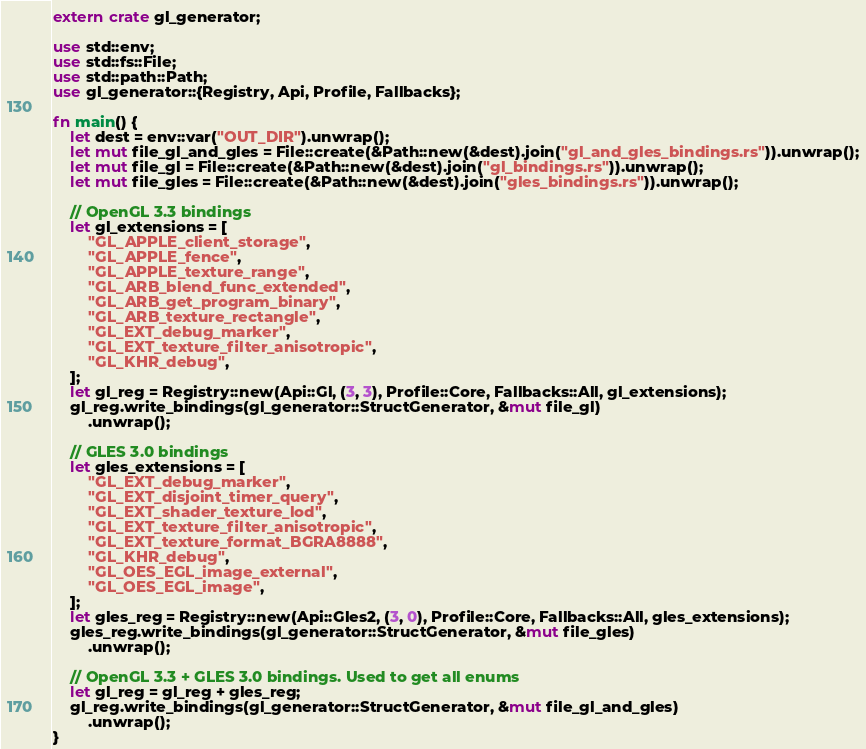<code> <loc_0><loc_0><loc_500><loc_500><_Rust_>extern crate gl_generator;

use std::env;
use std::fs::File;
use std::path::Path;
use gl_generator::{Registry, Api, Profile, Fallbacks};

fn main() {
    let dest = env::var("OUT_DIR").unwrap();
    let mut file_gl_and_gles = File::create(&Path::new(&dest).join("gl_and_gles_bindings.rs")).unwrap();
    let mut file_gl = File::create(&Path::new(&dest).join("gl_bindings.rs")).unwrap();
    let mut file_gles = File::create(&Path::new(&dest).join("gles_bindings.rs")).unwrap();

    // OpenGL 3.3 bindings
    let gl_extensions = [
        "GL_APPLE_client_storage",
        "GL_APPLE_fence",
        "GL_APPLE_texture_range",
        "GL_ARB_blend_func_extended",
        "GL_ARB_get_program_binary",
        "GL_ARB_texture_rectangle",
        "GL_EXT_debug_marker",
        "GL_EXT_texture_filter_anisotropic",
        "GL_KHR_debug",
    ];
    let gl_reg = Registry::new(Api::Gl, (3, 3), Profile::Core, Fallbacks::All, gl_extensions);
    gl_reg.write_bindings(gl_generator::StructGenerator, &mut file_gl)
        .unwrap();

    // GLES 3.0 bindings
    let gles_extensions = [
        "GL_EXT_debug_marker",
        "GL_EXT_disjoint_timer_query",
        "GL_EXT_shader_texture_lod",
        "GL_EXT_texture_filter_anisotropic",
        "GL_EXT_texture_format_BGRA8888",
        "GL_KHR_debug",
        "GL_OES_EGL_image_external",
        "GL_OES_EGL_image",
    ];
    let gles_reg = Registry::new(Api::Gles2, (3, 0), Profile::Core, Fallbacks::All, gles_extensions);
    gles_reg.write_bindings(gl_generator::StructGenerator, &mut file_gles)
        .unwrap();

    // OpenGL 3.3 + GLES 3.0 bindings. Used to get all enums
    let gl_reg = gl_reg + gles_reg;
    gl_reg.write_bindings(gl_generator::StructGenerator, &mut file_gl_and_gles)
        .unwrap();
}
</code> 